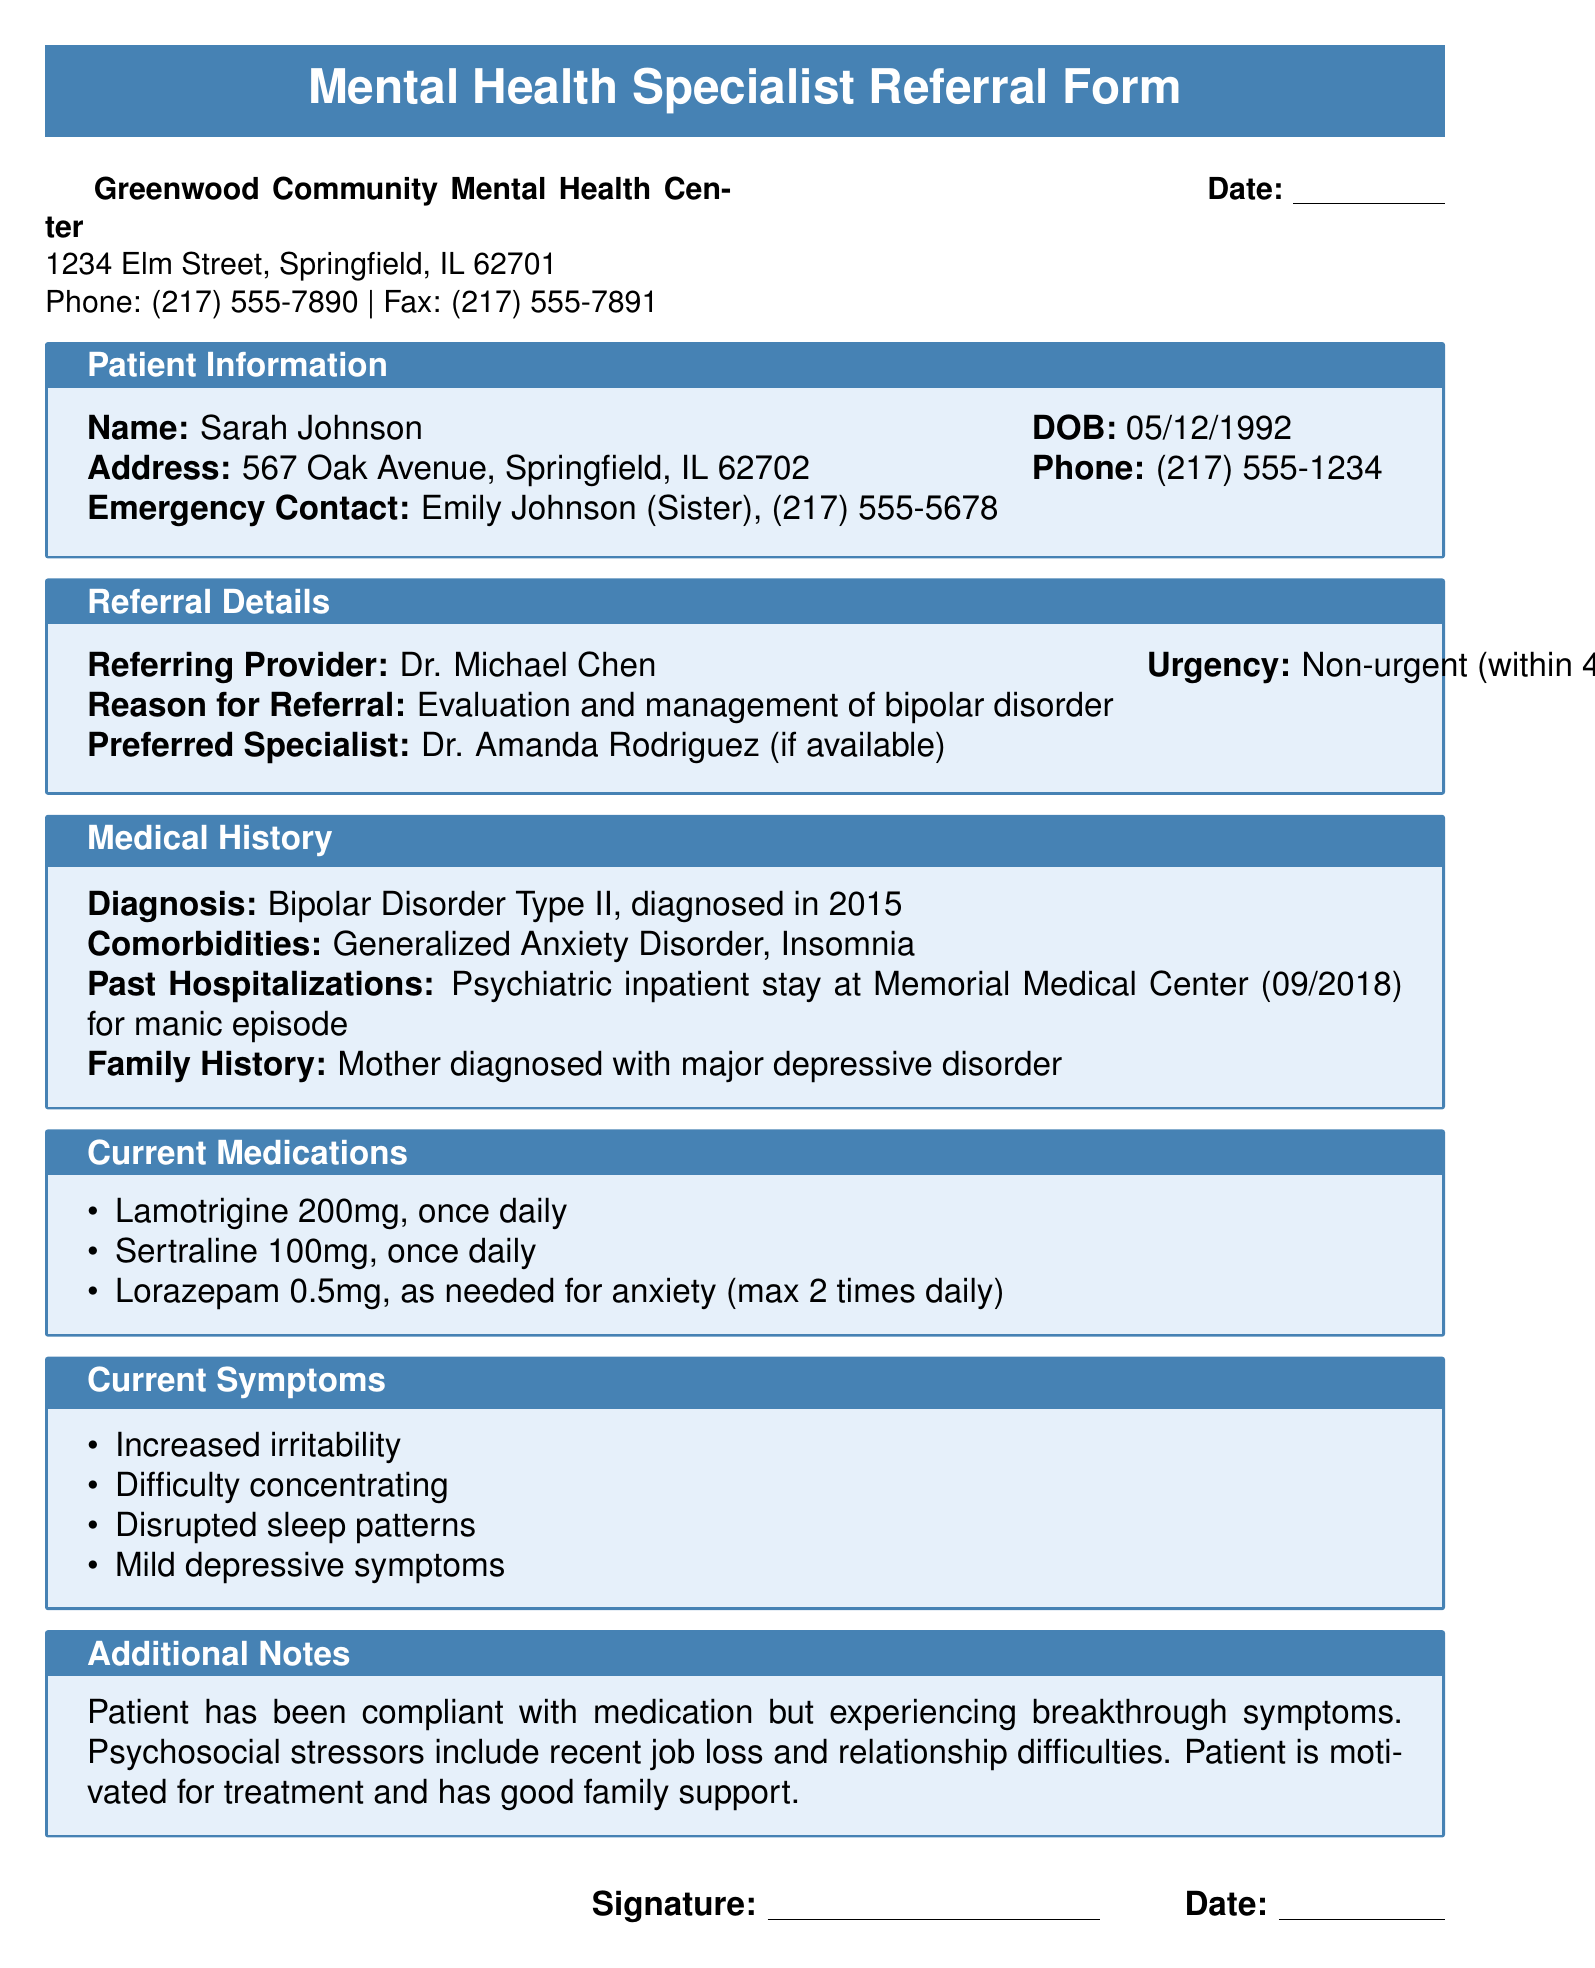What is the name of the patient? The patient's name is mentioned at the top of the document under Patient Information.
Answer: Sarah Johnson What is the date of birth of the patient? The date of birth is provided in the Patient Information section.
Answer: 05/12/1992 What is the reason for referral? The reason is specified under Referral Details.
Answer: Evaluation and management of bipolar disorder Who is the referring provider? The name of the referring provider is stated in the Referral Details section.
Answer: Dr. Michael Chen What medication is prescribed for anxiety? The current medications listed include one specifically for anxiety.
Answer: Lorazepam How many times daily is the medication for depression taken? The frequency of the medication for depression is mentioned in the Current Medications section.
Answer: Once daily What was the patient's last psychiatric inpatient stay? The document states the past hospitalization under Medical History.
Answer: 09/2018 What current symptoms are listed for the patient? The symptoms are enumerated in the Current Symptoms section.
Answer: Increased irritability How many medications are currently listed? The total number of medications is mentioned in the Current Medications section.
Answer: Three What additional psychosocial stressor is noted for the patient? The Additional Notes section mentions specific psychosocial stressors.
Answer: Job loss 